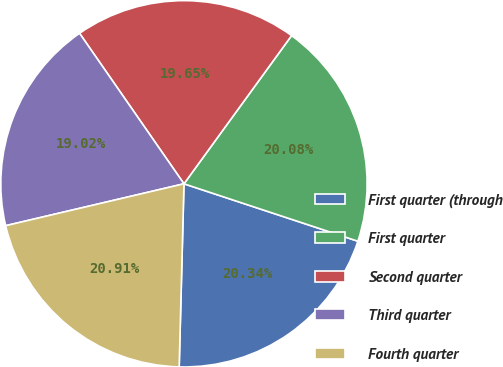Convert chart to OTSL. <chart><loc_0><loc_0><loc_500><loc_500><pie_chart><fcel>First quarter (through<fcel>First quarter<fcel>Second quarter<fcel>Third quarter<fcel>Fourth quarter<nl><fcel>20.34%<fcel>20.08%<fcel>19.65%<fcel>19.02%<fcel>20.91%<nl></chart> 